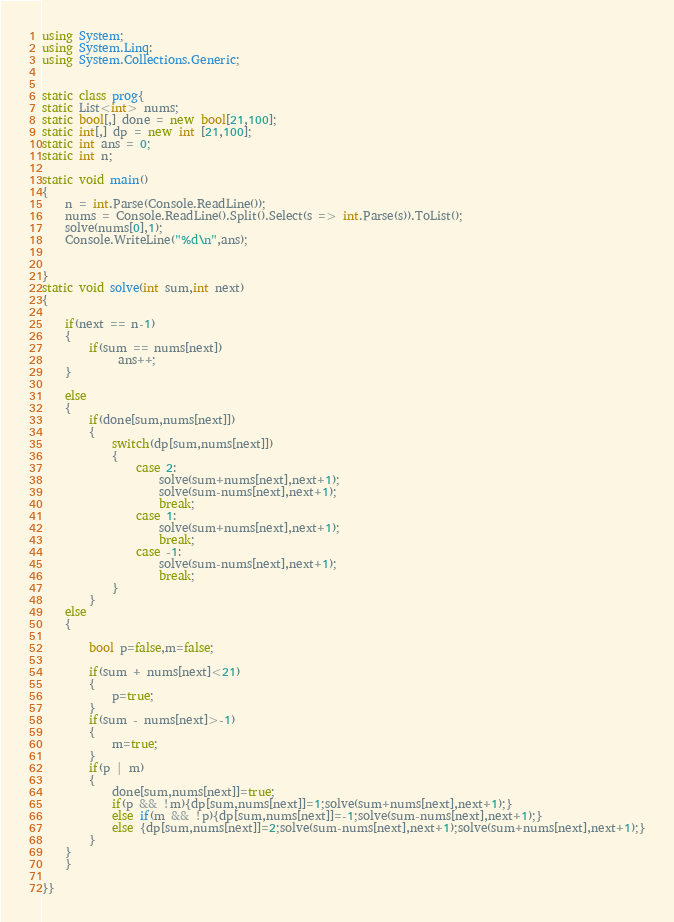<code> <loc_0><loc_0><loc_500><loc_500><_C#_>using System;
using System.Linq:
using System.Collections.Generic;


static class prog{
static List<int> nums;
static bool[,] done = new bool[21,100];
static int[,] dp = new int [21,100];
static int ans = 0;
static int n;

static void main()
{
    n = int.Parse(Console.ReadLine());
    nums = Console.ReadLine().Split().Select(s => int.Parse(s)).ToList();
    solve(nums[0],1);
    Console.WriteLine("%d\n",ans);


}
static void solve(int sum,int next)
{

    if(next == n-1)
    {
        if(sum == nums[next])
             ans++;
    }

    else
    {
        if(done[sum,nums[next]])
        {
            switch(dp[sum,nums[next]])
            {
                case 2:
                    solve(sum+nums[next],next+1);
                    solve(sum-nums[next],next+1);
                    break;
                case 1:
                    solve(sum+nums[next],next+1);
                    break;
                case -1:
                    solve(sum-nums[next],next+1);
                    break;
            }
        }
	else
	{

        bool p=false,m=false;
     
        if(sum + nums[next]<21)
        {
            p=true;
        }
        if(sum - nums[next]>-1)
        {
            m=true;
        }
        if(p | m)
        {
            done[sum,nums[next]]=true;
            if(p && !m){dp[sum,nums[next]]=1;solve(sum+nums[next],next+1);}
            else if(m && !p){dp[sum,nums[next]]=-1;solve(sum-nums[next],next+1);}
            else {dp[sum,nums[next]]=2;solve(sum-nums[next],next+1);solve(sum+nums[next],next+1);}
        }
	}
    }

}}</code> 